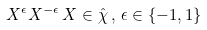Convert formula to latex. <formula><loc_0><loc_0><loc_500><loc_500>X ^ { \epsilon } X ^ { - \epsilon } \, X \in \hat { \chi } \, , \, \epsilon \in \{ - 1 , 1 \}</formula> 